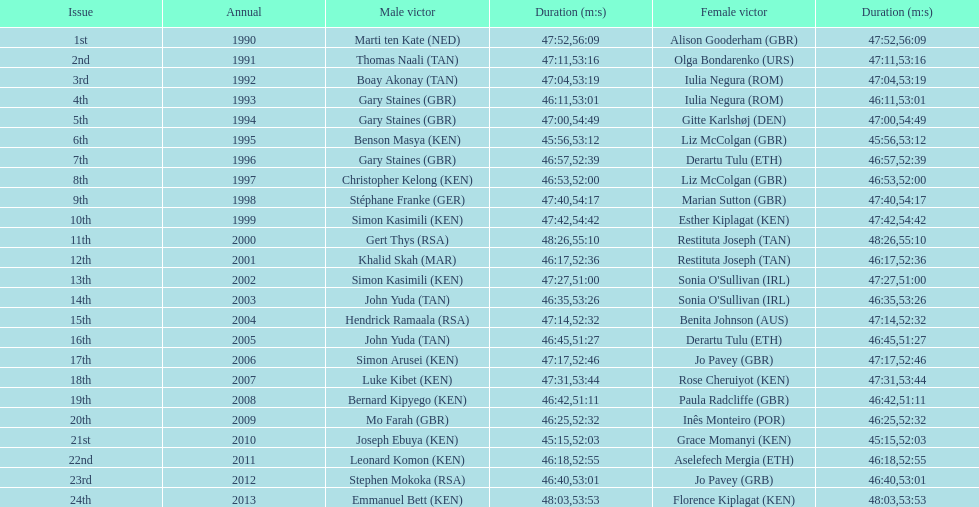Who is the male winner listed before gert thys? Simon Kasimili. 